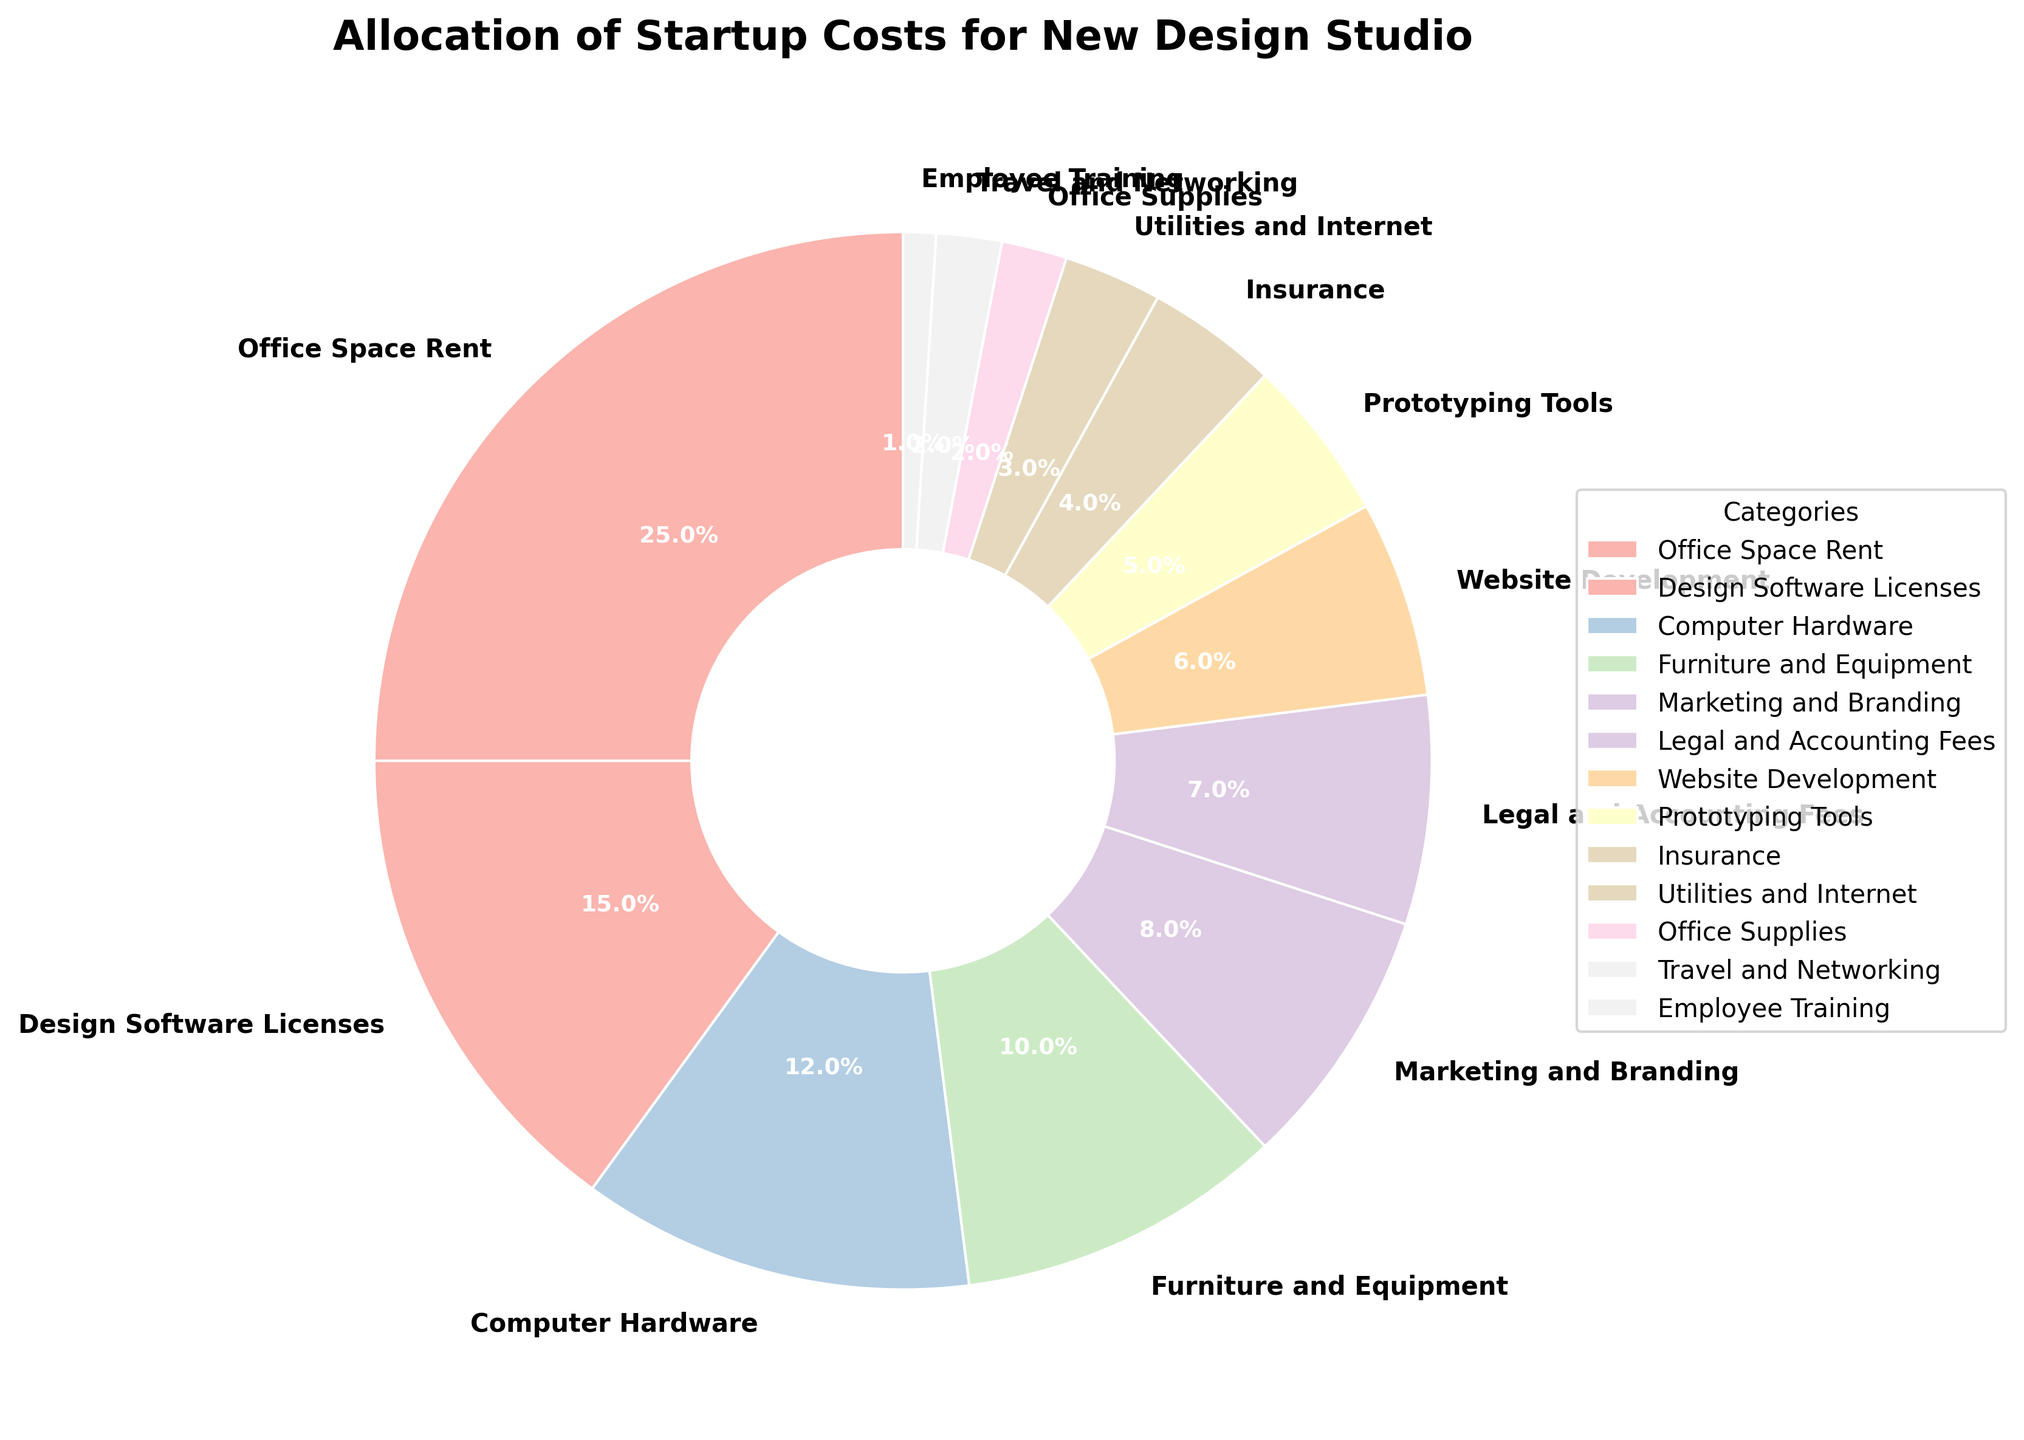What category has the largest allocation of startup costs? The pie chart shows each category's percentage of the startup costs. The largest segment or wedge in the pie chart represents the largest allocation. According to the pie chart, Office Space Rent has the largest allocation.
Answer: Office Space Rent What is the combined percentage of costs allocated to Legal and Accounting Fees, Website Development, and Prototyping Tools? To find the combined percentage, sum the individual percentages: Legal and Accounting Fees (7%), Website Development (6%), and Prototyping Tools (5%). The total is 7% + 6% + 5%.
Answer: 18% Which category has a larger allocation: Marketing and Branding or Computer Hardware? The pie chart segments show that Marketing and Branding is 8% while Computer Hardware is 12%. Comparing these values, Computer Hardware has a larger allocation.
Answer: Computer Hardware What is the difference in percentage allocation between Office Space Rent and Furniture and Equipment? From the chart, Office Space Rent is 25% and Furniture and Equipment is 10%. Subtract the percentage of Furniture and Equipment from Office Space Rent: 25% - 10%.
Answer: 15% Which category has the smallest allocation, and what percentage is it? The smallest segment or wedge of the pie chart represents the smallest allocation. According to the pie chart, Employee Training has the smallest allocation, which is 1%.
Answer: Employee Training, 1% What is the total percentage allocated to categories related to office-related expenses (Office Space Rent, Furniture and Equipment, Utilities and Internet, Office Supplies)? Sum the percentages for these categories: Office Space Rent (25%), Furniture and Equipment (10%), Utilities and Internet (3%), and Office Supplies (2%) gives us 25% + 10% + 3% + 2%.
Answer: 40% How does the allocation for Insurance compare to that for Marketing and Branding? From the pie chart, Insurance is allocated 4% and Marketing and Branding is allocated 8%. Comparing these values, Marketing and Branding has a higher allocation than Insurance.
Answer: Marketing and Branding has double the allocation of Insurance Is the allocation for Travel and Networking greater or less than the allocation for Employee Training? The pie chart shows Travel and Networking allocated 2% and Employee Training allocated 1%. Comparing these values, Travel and Networking has a greater allocation.
Answer: Travel and Networking What categories have an equal percentage allocation, and what is that percentage? According to the pie chart, Travel and Networking and Office Supplies both have an allocation of 2%.
Answer: Travel and Networking, Office Supplies, 2% 